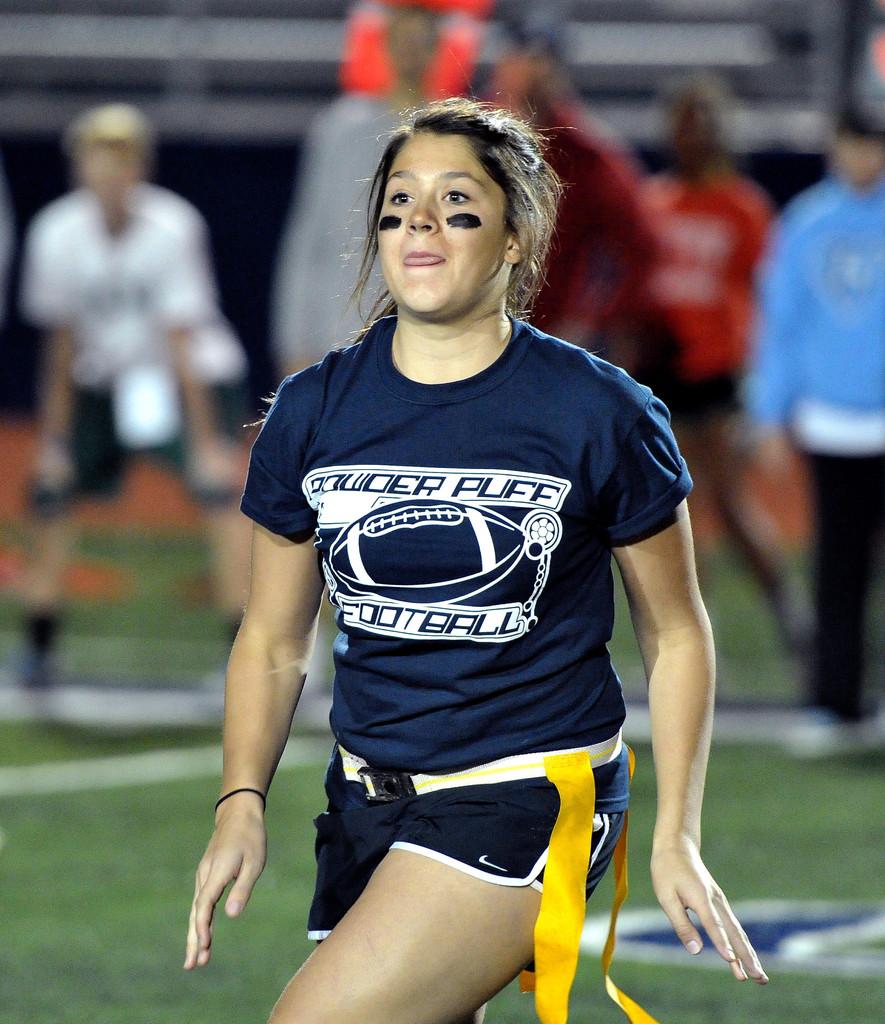What sport is being played?
Offer a very short reply. Football. 